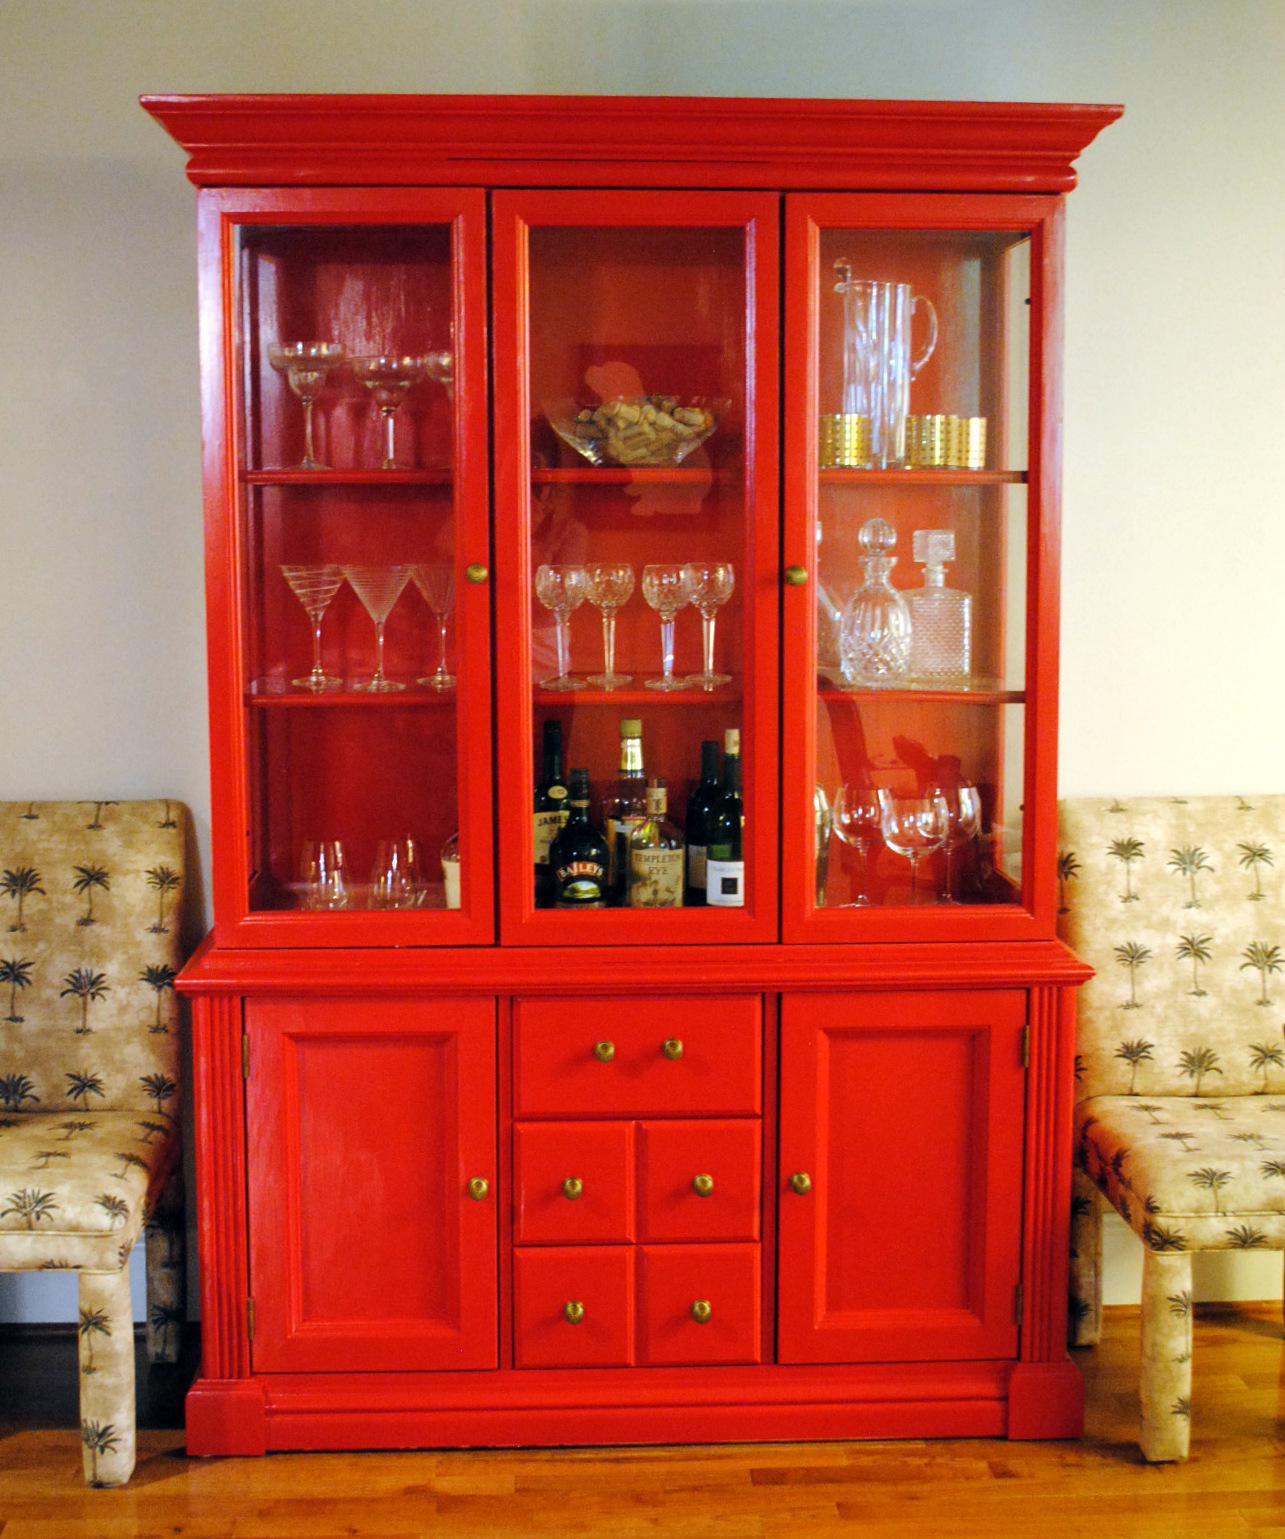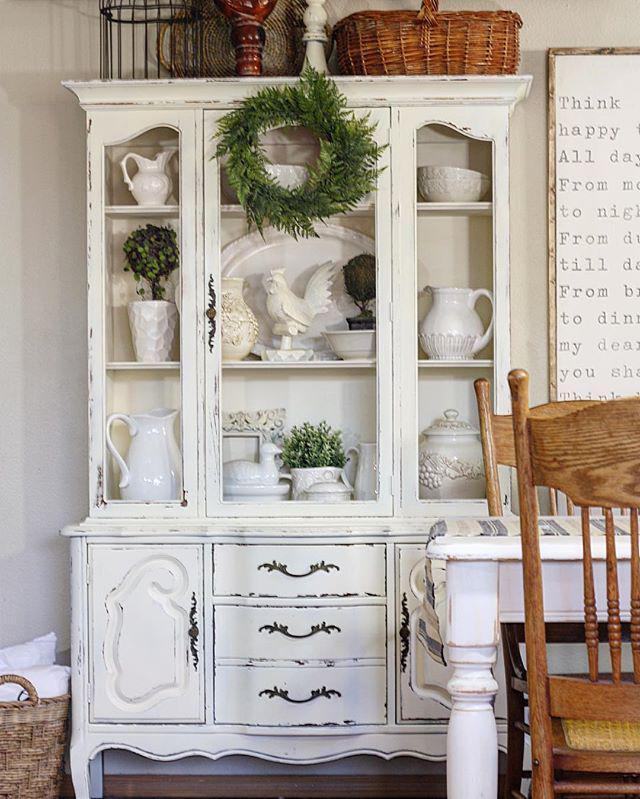The first image is the image on the left, the second image is the image on the right. Evaluate the accuracy of this statement regarding the images: "One of the cabinets against the wall is white.". Is it true? Answer yes or no. Yes. The first image is the image on the left, the second image is the image on the right. Evaluate the accuracy of this statement regarding the images: "An image shows a white cabinet with feet and a scroll-curved bottom.". Is it true? Answer yes or no. Yes. 